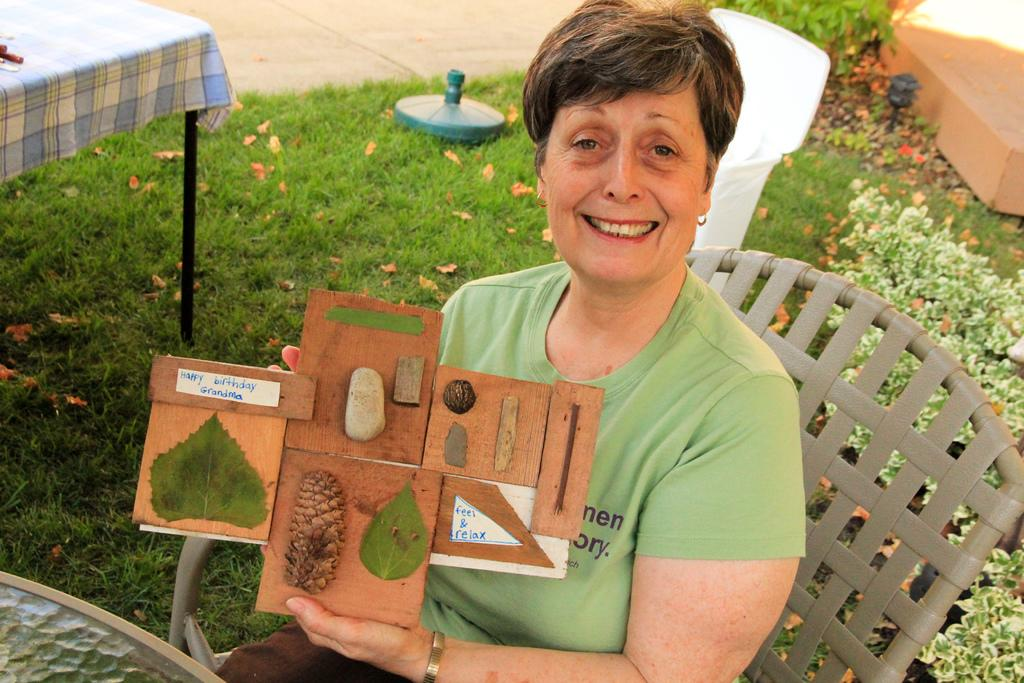Who is the main subject in the image? There is a woman in the image. What is the woman doing in the image? The woman is sitting on a chair. What is the woman holding in the image? The woman is holding a wooden sheet. What is the woman wearing in the image? The woman is wearing a green t-shirt. What can be seen on the right side of the image? There are small plants on the right side of the image. What type of behavior does the woman exhibit towards her mother in the image? There is no indication of a mother or any behavior towards her in the image. 